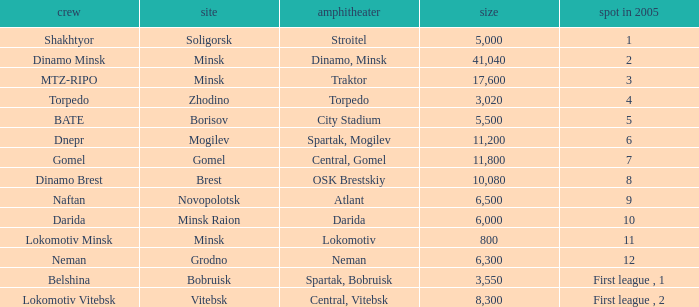I'm looking to parse the entire table for insights. Could you assist me with that? {'header': ['crew', 'site', 'amphitheater', 'size', 'spot in 2005'], 'rows': [['Shakhtyor', 'Soligorsk', 'Stroitel', '5,000', '1'], ['Dinamo Minsk', 'Minsk', 'Dinamo, Minsk', '41,040', '2'], ['MTZ-RIPO', 'Minsk', 'Traktor', '17,600', '3'], ['Torpedo', 'Zhodino', 'Torpedo', '3,020', '4'], ['BATE', 'Borisov', 'City Stadium', '5,500', '5'], ['Dnepr', 'Mogilev', 'Spartak, Mogilev', '11,200', '6'], ['Gomel', 'Gomel', 'Central, Gomel', '11,800', '7'], ['Dinamo Brest', 'Brest', 'OSK Brestskiy', '10,080', '8'], ['Naftan', 'Novopolotsk', 'Atlant', '6,500', '9'], ['Darida', 'Minsk Raion', 'Darida', '6,000', '10'], ['Lokomotiv Minsk', 'Minsk', 'Lokomotiv', '800', '11'], ['Neman', 'Grodno', 'Neman', '6,300', '12'], ['Belshina', 'Bobruisk', 'Spartak, Bobruisk', '3,550', 'First league , 1'], ['Lokomotiv Vitebsk', 'Vitebsk', 'Central, Vitebsk', '8,300', 'First league , 2']]} Can you tell me the highest Capacity that has the Team of torpedo? 3020.0. 